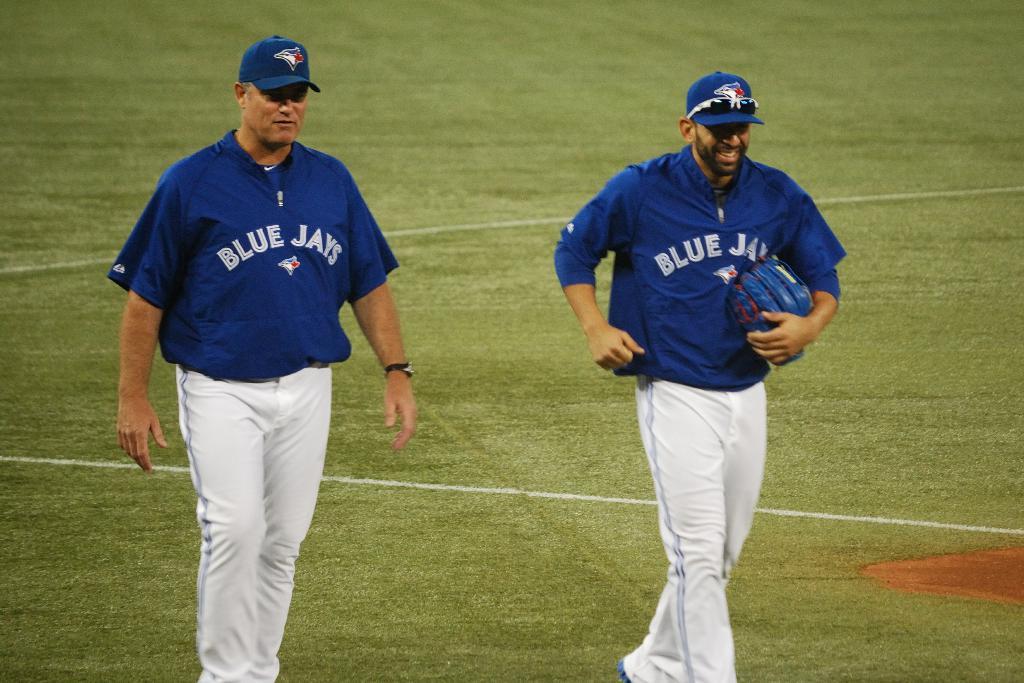What is the team name on their jerseys?
Give a very brief answer. Blue jays. 